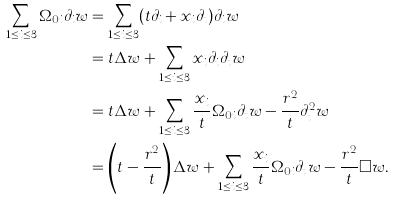<formula> <loc_0><loc_0><loc_500><loc_500>\sum _ { 1 \leq i \leq 3 } \Omega _ { 0 i } \partial _ { i } w & = \sum _ { 1 \leq i \leq 3 } ( t \partial _ { i } + x _ { i } \partial _ { t } ) \partial _ { i } w \\ & = t \Delta w + \sum _ { 1 \leq i \leq 3 } x _ { i } \partial _ { i } \partial _ { t } w \\ & = t \Delta w + \sum _ { 1 \leq i \leq 3 } \frac { x _ { i } } { t } \Omega _ { 0 i } \partial _ { t } w - \frac { r ^ { 2 } } { t } \partial _ { t } ^ { 2 } w \\ & = \left ( t - \frac { r ^ { 2 } } { t } \right ) \Delta w + \sum _ { 1 \leq i \leq 3 } \frac { x _ { i } } { t } \Omega _ { 0 i } \partial _ { t } w - \frac { r ^ { 2 } } { t } \Box w .</formula> 